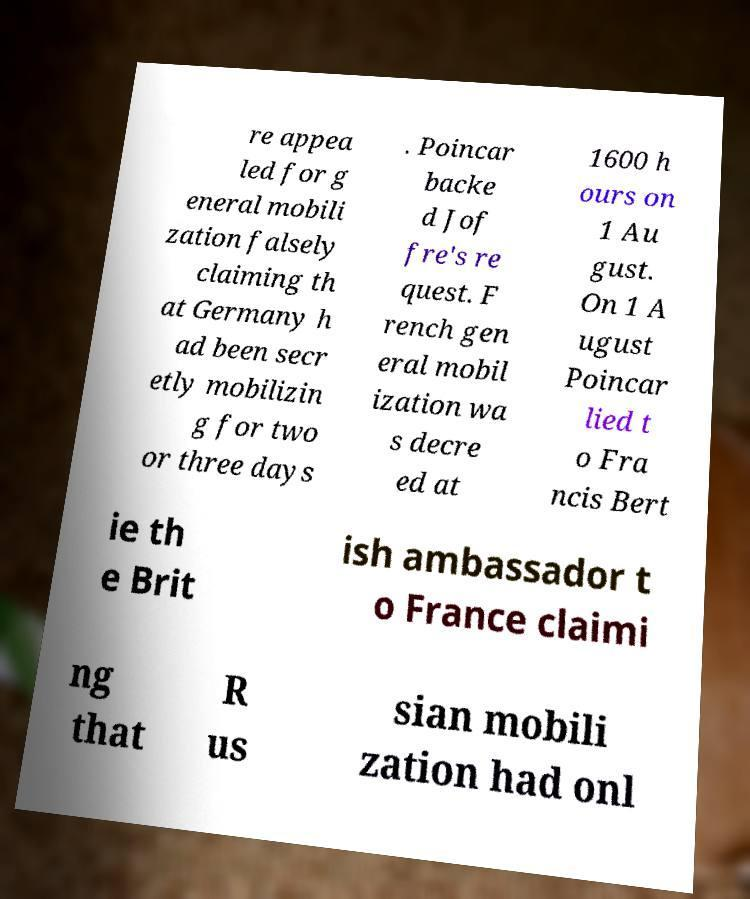There's text embedded in this image that I need extracted. Can you transcribe it verbatim? re appea led for g eneral mobili zation falsely claiming th at Germany h ad been secr etly mobilizin g for two or three days . Poincar backe d Jof fre's re quest. F rench gen eral mobil ization wa s decre ed at 1600 h ours on 1 Au gust. On 1 A ugust Poincar lied t o Fra ncis Bert ie th e Brit ish ambassador t o France claimi ng that R us sian mobili zation had onl 